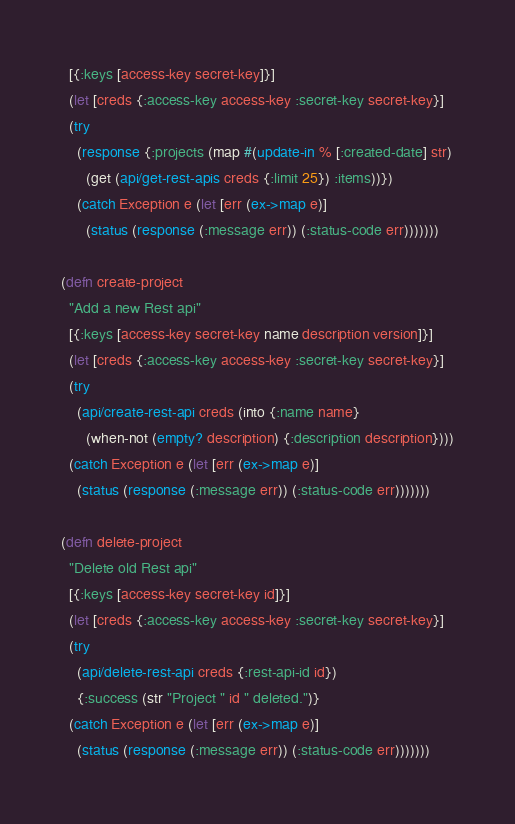<code> <loc_0><loc_0><loc_500><loc_500><_Clojure_>  [{:keys [access-key secret-key]}]
  (let [creds {:access-key access-key :secret-key secret-key}]
  (try
    (response {:projects (map #(update-in % [:created-date] str)
      (get (api/get-rest-apis creds {:limit 25}) :items))})
    (catch Exception e (let [err (ex->map e)]
      (status (response (:message err)) (:status-code err)))))))

(defn create-project
  "Add a new Rest api"
  [{:keys [access-key secret-key name description version]}]
  (let [creds {:access-key access-key :secret-key secret-key}]
  (try
    (api/create-rest-api creds (into {:name name}
      (when-not (empty? description) {:description description})))
  (catch Exception e (let [err (ex->map e)]
    (status (response (:message err)) (:status-code err)))))))

(defn delete-project
  "Delete old Rest api"
  [{:keys [access-key secret-key id]}]
  (let [creds {:access-key access-key :secret-key secret-key}]
  (try
    (api/delete-rest-api creds {:rest-api-id id})
    {:success (str "Project " id " deleted.")}
  (catch Exception e (let [err (ex->map e)]
    (status (response (:message err)) (:status-code err)))))))
</code> 